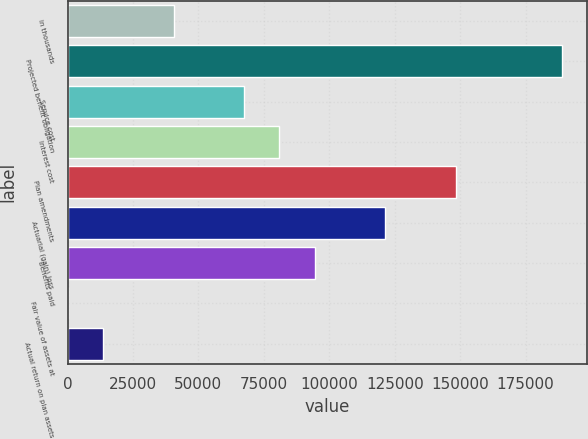Convert chart to OTSL. <chart><loc_0><loc_0><loc_500><loc_500><bar_chart><fcel>in thousands<fcel>Projected benefit obligation<fcel>Service cost<fcel>Interest cost<fcel>Plan amendments<fcel>Actuarial (gain) loss<fcel>Benefits paid<fcel>Fair value of assets at<fcel>Actual return on plan assets<nl><fcel>40478.7<fcel>188896<fcel>67463.6<fcel>80956.1<fcel>148418<fcel>121434<fcel>94448.6<fcel>1.21<fcel>13493.7<nl></chart> 